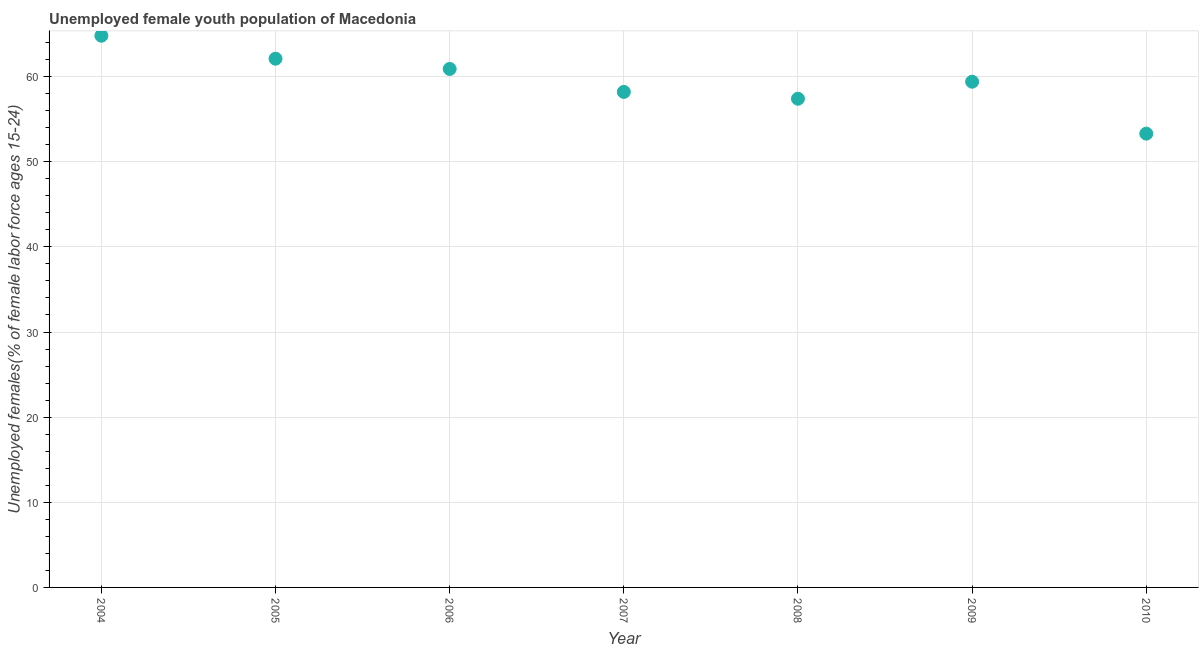What is the unemployed female youth in 2009?
Your answer should be compact. 59.4. Across all years, what is the maximum unemployed female youth?
Provide a succinct answer. 64.8. Across all years, what is the minimum unemployed female youth?
Provide a succinct answer. 53.3. What is the sum of the unemployed female youth?
Provide a short and direct response. 416.1. What is the difference between the unemployed female youth in 2004 and 2010?
Keep it short and to the point. 11.5. What is the average unemployed female youth per year?
Your answer should be very brief. 59.44. What is the median unemployed female youth?
Your answer should be compact. 59.4. In how many years, is the unemployed female youth greater than 32 %?
Your answer should be very brief. 7. What is the ratio of the unemployed female youth in 2007 to that in 2008?
Offer a very short reply. 1.01. What is the difference between the highest and the second highest unemployed female youth?
Provide a short and direct response. 2.7. What is the difference between the highest and the lowest unemployed female youth?
Make the answer very short. 11.5. In how many years, is the unemployed female youth greater than the average unemployed female youth taken over all years?
Ensure brevity in your answer.  3. Does the unemployed female youth monotonically increase over the years?
Provide a short and direct response. No. Are the values on the major ticks of Y-axis written in scientific E-notation?
Offer a very short reply. No. Does the graph contain grids?
Make the answer very short. Yes. What is the title of the graph?
Keep it short and to the point. Unemployed female youth population of Macedonia. What is the label or title of the Y-axis?
Provide a short and direct response. Unemployed females(% of female labor force ages 15-24). What is the Unemployed females(% of female labor force ages 15-24) in 2004?
Your response must be concise. 64.8. What is the Unemployed females(% of female labor force ages 15-24) in 2005?
Provide a succinct answer. 62.1. What is the Unemployed females(% of female labor force ages 15-24) in 2006?
Your answer should be compact. 60.9. What is the Unemployed females(% of female labor force ages 15-24) in 2007?
Keep it short and to the point. 58.2. What is the Unemployed females(% of female labor force ages 15-24) in 2008?
Your answer should be very brief. 57.4. What is the Unemployed females(% of female labor force ages 15-24) in 2009?
Provide a succinct answer. 59.4. What is the Unemployed females(% of female labor force ages 15-24) in 2010?
Provide a short and direct response. 53.3. What is the difference between the Unemployed females(% of female labor force ages 15-24) in 2004 and 2007?
Your response must be concise. 6.6. What is the difference between the Unemployed females(% of female labor force ages 15-24) in 2004 and 2008?
Make the answer very short. 7.4. What is the difference between the Unemployed females(% of female labor force ages 15-24) in 2004 and 2009?
Give a very brief answer. 5.4. What is the difference between the Unemployed females(% of female labor force ages 15-24) in 2004 and 2010?
Provide a succinct answer. 11.5. What is the difference between the Unemployed females(% of female labor force ages 15-24) in 2005 and 2007?
Offer a very short reply. 3.9. What is the difference between the Unemployed females(% of female labor force ages 15-24) in 2005 and 2008?
Make the answer very short. 4.7. What is the difference between the Unemployed females(% of female labor force ages 15-24) in 2005 and 2009?
Offer a terse response. 2.7. What is the difference between the Unemployed females(% of female labor force ages 15-24) in 2005 and 2010?
Offer a very short reply. 8.8. What is the difference between the Unemployed females(% of female labor force ages 15-24) in 2006 and 2007?
Make the answer very short. 2.7. What is the difference between the Unemployed females(% of female labor force ages 15-24) in 2006 and 2008?
Offer a terse response. 3.5. What is the difference between the Unemployed females(% of female labor force ages 15-24) in 2006 and 2009?
Ensure brevity in your answer.  1.5. What is the difference between the Unemployed females(% of female labor force ages 15-24) in 2009 and 2010?
Keep it short and to the point. 6.1. What is the ratio of the Unemployed females(% of female labor force ages 15-24) in 2004 to that in 2005?
Keep it short and to the point. 1.04. What is the ratio of the Unemployed females(% of female labor force ages 15-24) in 2004 to that in 2006?
Give a very brief answer. 1.06. What is the ratio of the Unemployed females(% of female labor force ages 15-24) in 2004 to that in 2007?
Provide a succinct answer. 1.11. What is the ratio of the Unemployed females(% of female labor force ages 15-24) in 2004 to that in 2008?
Provide a succinct answer. 1.13. What is the ratio of the Unemployed females(% of female labor force ages 15-24) in 2004 to that in 2009?
Offer a very short reply. 1.09. What is the ratio of the Unemployed females(% of female labor force ages 15-24) in 2004 to that in 2010?
Provide a succinct answer. 1.22. What is the ratio of the Unemployed females(% of female labor force ages 15-24) in 2005 to that in 2007?
Keep it short and to the point. 1.07. What is the ratio of the Unemployed females(% of female labor force ages 15-24) in 2005 to that in 2008?
Keep it short and to the point. 1.08. What is the ratio of the Unemployed females(% of female labor force ages 15-24) in 2005 to that in 2009?
Make the answer very short. 1.04. What is the ratio of the Unemployed females(% of female labor force ages 15-24) in 2005 to that in 2010?
Make the answer very short. 1.17. What is the ratio of the Unemployed females(% of female labor force ages 15-24) in 2006 to that in 2007?
Ensure brevity in your answer.  1.05. What is the ratio of the Unemployed females(% of female labor force ages 15-24) in 2006 to that in 2008?
Make the answer very short. 1.06. What is the ratio of the Unemployed females(% of female labor force ages 15-24) in 2006 to that in 2010?
Provide a succinct answer. 1.14. What is the ratio of the Unemployed females(% of female labor force ages 15-24) in 2007 to that in 2010?
Provide a succinct answer. 1.09. What is the ratio of the Unemployed females(% of female labor force ages 15-24) in 2008 to that in 2009?
Ensure brevity in your answer.  0.97. What is the ratio of the Unemployed females(% of female labor force ages 15-24) in 2008 to that in 2010?
Your answer should be very brief. 1.08. What is the ratio of the Unemployed females(% of female labor force ages 15-24) in 2009 to that in 2010?
Offer a very short reply. 1.11. 